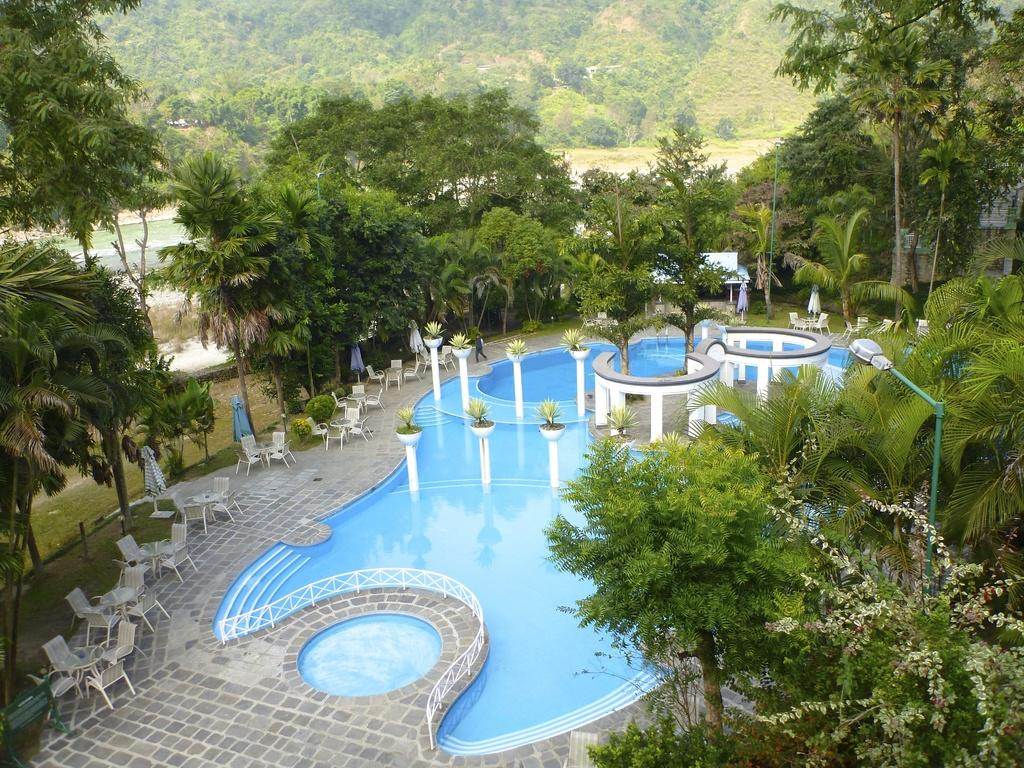What is the main feature in the image? There is a swimming pool in the image. What other objects or elements can be seen in the image? There are plants, chairs, trees, and a hill visible in the background of the image. What thought is the swimming pool having in the image? Swimming pools do not have thoughts, as they are inanimate objects. 